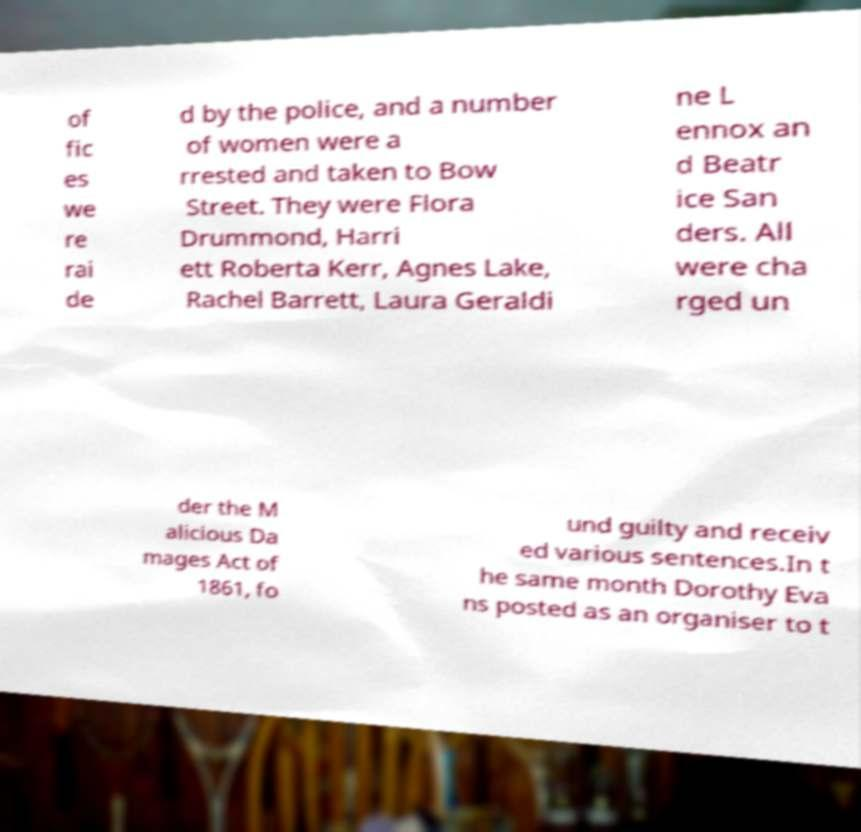Please identify and transcribe the text found in this image. of fic es we re rai de d by the police, and a number of women were a rrested and taken to Bow Street. They were Flora Drummond, Harri ett Roberta Kerr, Agnes Lake, Rachel Barrett, Laura Geraldi ne L ennox an d Beatr ice San ders. All were cha rged un der the M alicious Da mages Act of 1861, fo und guilty and receiv ed various sentences.In t he same month Dorothy Eva ns posted as an organiser to t 